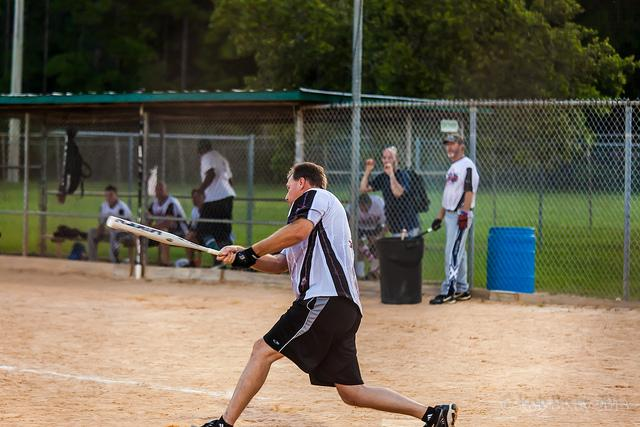What is the most common usage of the black container? Please explain your reasoning. garbage. The black container is a trash can. 